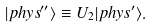Convert formula to latex. <formula><loc_0><loc_0><loc_500><loc_500>| { p h y s ^ { \prime \prime } } \rangle \equiv U _ { 2 } | { p h y s } ^ { \prime } \rangle .</formula> 